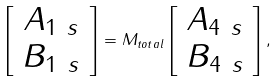Convert formula to latex. <formula><loc_0><loc_0><loc_500><loc_500>\left [ \begin{array} { c } A _ { 1 \ s } \\ B _ { 1 \ s } \end{array} \right ] = M _ { t o t a l } \left [ \begin{array} { c } A _ { 4 \ s } \\ B _ { 4 \ s } \end{array} \right ] ,</formula> 